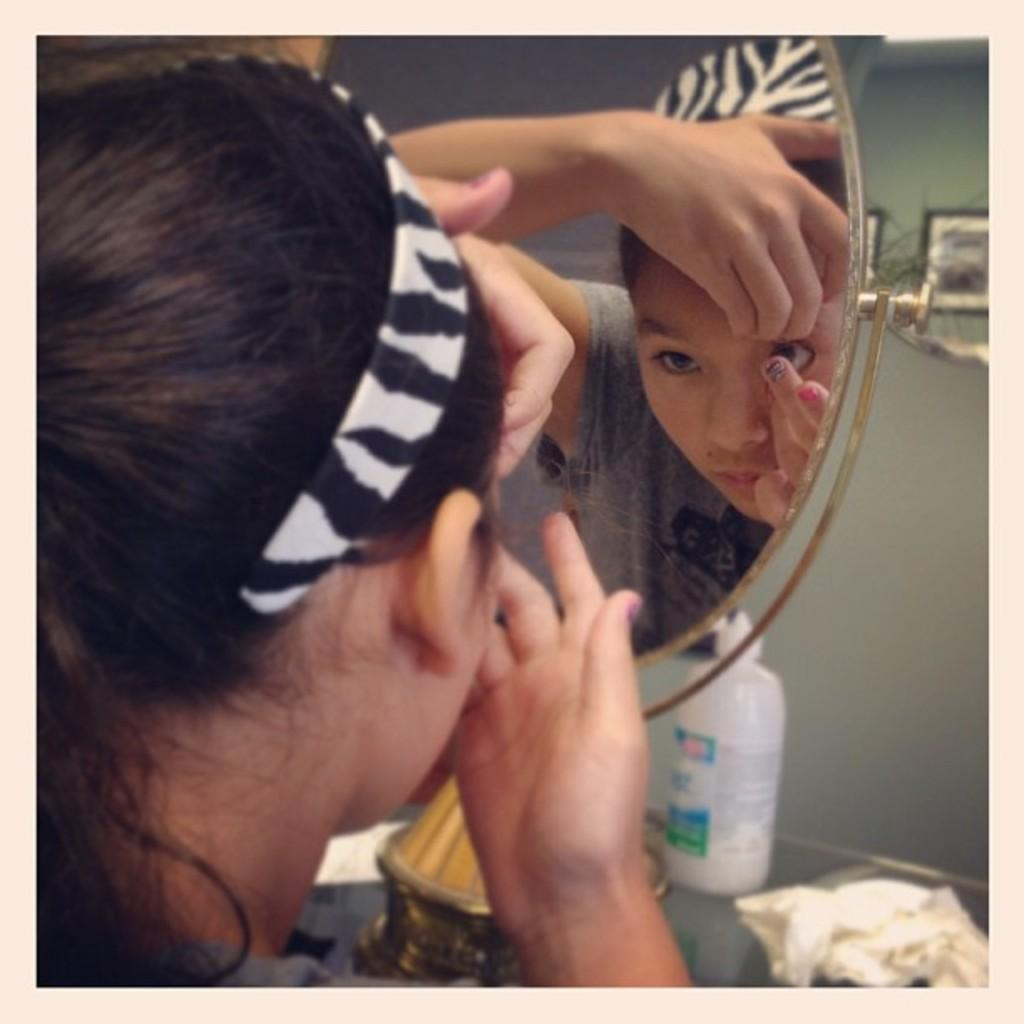Who is present in the image? There is a lady in the image. What is the lady wearing on her head? The lady is wearing a hairband. What is the lady doing in the image? The lady is looking at a mirror. What can be seen at the bottom of the image? There are bottles at the bottom of the image. What else is visible in the image besides the lady and the bottles? There are objects visible in the image. What is visible in the background of the image? There is a wall in the background of the image. What color is the blood on the lady's hand in the image? There is no blood visible on the lady's hand in the image. What type of experience does the lady have with the objects in the image? The image does not provide any information about the lady's experience with the objects. 